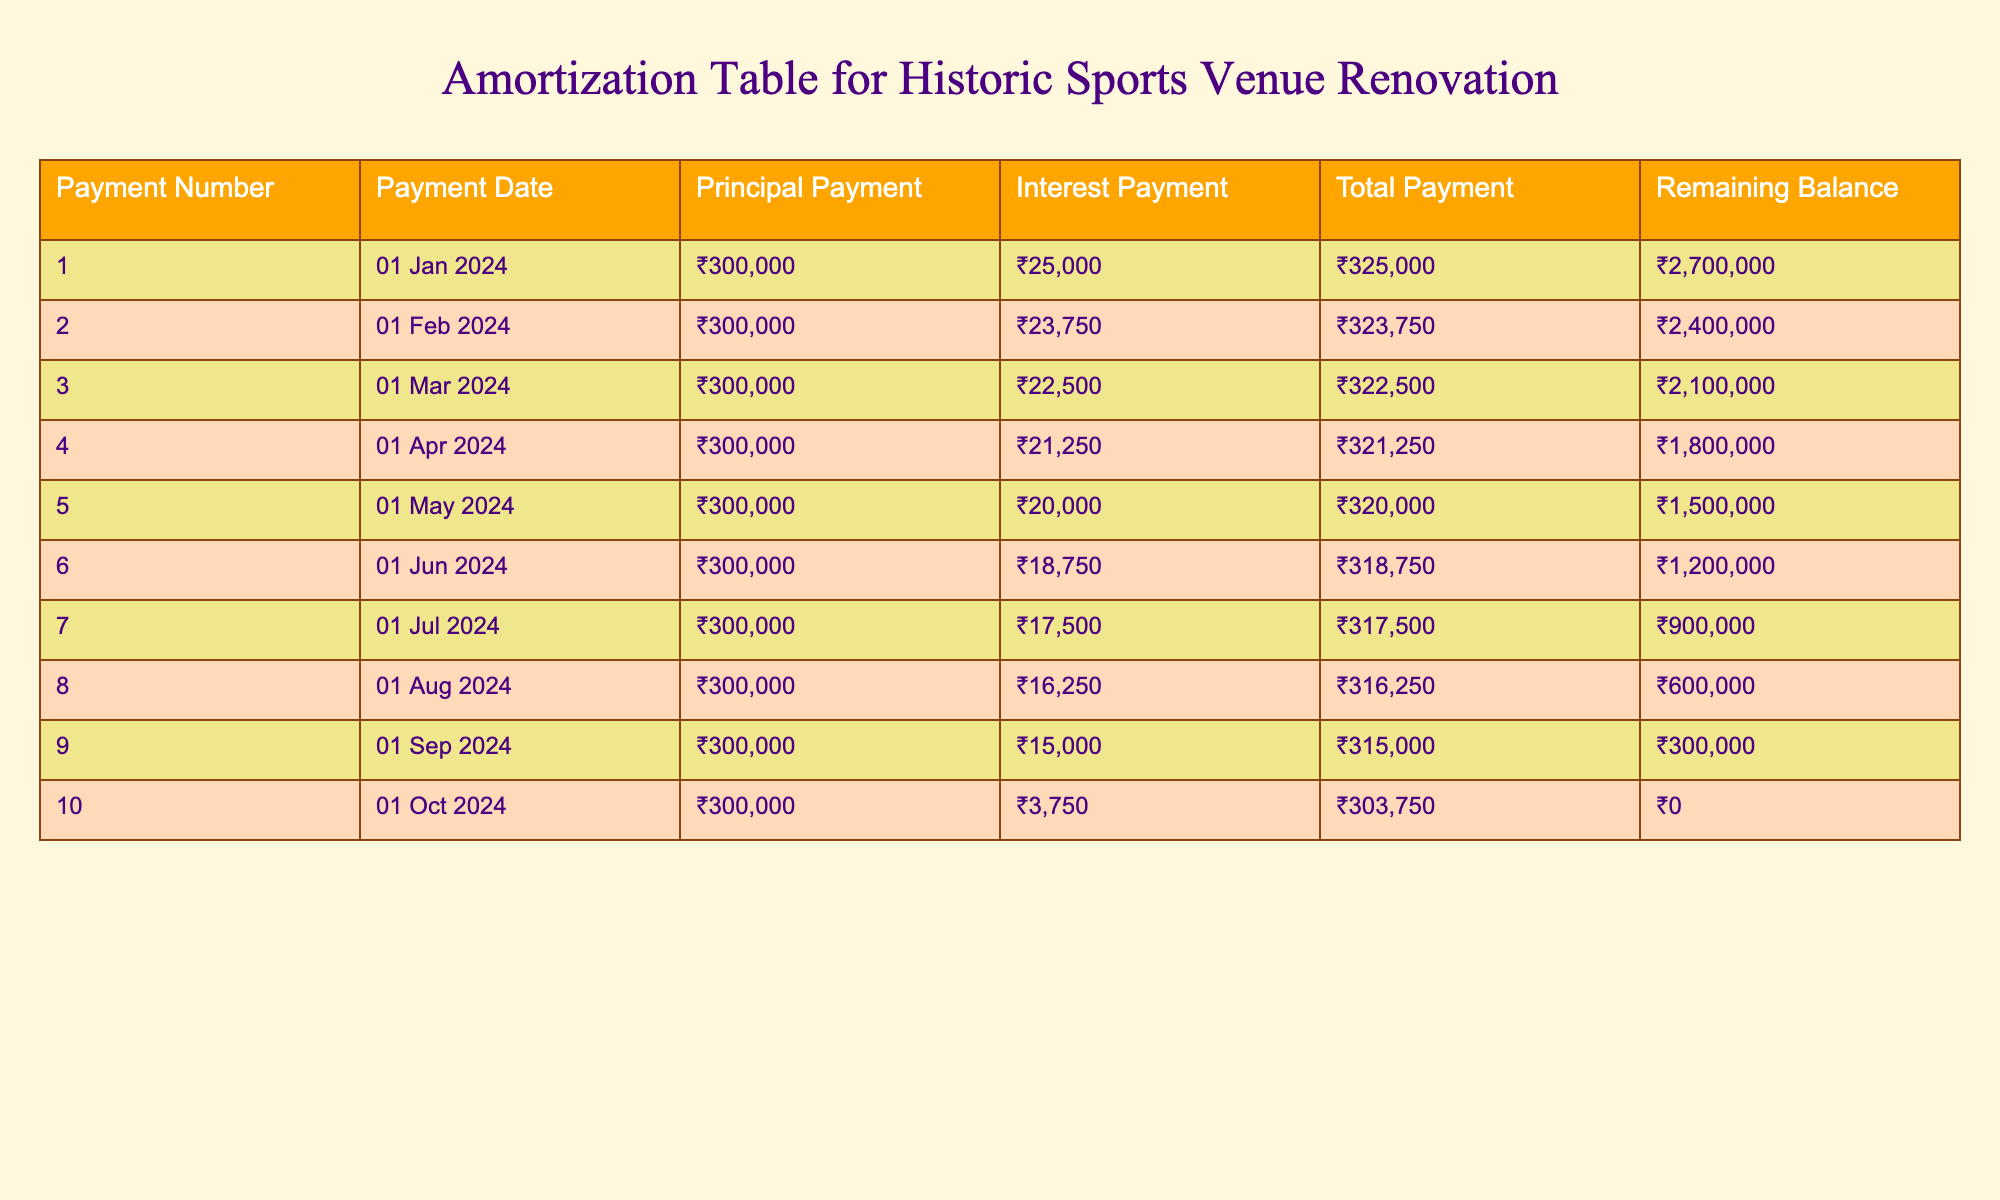What is the total payment made in the first month? The total payment for the first month is listed under the "Total Payment" column for Payment Number 1, which is ₹325,000.
Answer: ₹325,000 How much was the principal payment in the fifth month? The principal payment for the fifth month can be found in the "Principal Payment" column for Payment Number 5, which is ₹300,000.
Answer: ₹300,000 What is the remaining balance after the tenth payment? The remaining balance is shown in the "Remaining Balance" column for Payment Number 10, which indicates ₹0.
Answer: ₹0 What is the total interest paid over the ten months? The total interest paid over the ten months is the sum of the "Interest Payment" column. Summing the values (₹25,000 + ₹23,750 + ₹22,500 + ₹21,250 + ₹20,000 + ₹18,750 + ₹17,500 + ₹16,250 + ₹15,000 + ₹3,750) equals ₹194,000.
Answer: ₹194,000 Was the interest payment in the sixth month higher than in the ninth month? The interest payment in the sixth month is ₹18,750 while in the ninth month it is ₹15,000. Since ₹18,750 is greater than ₹15,000, the statement is true.
Answer: Yes What is the average principal payment made each month? There are ten months, and each month has a principal payment of ₹300,000. Thus, the average principal payment is simply ₹300,000 since all values are the same.
Answer: ₹300,000 How much did the total payments decrease from the first to the last month? The total payment in the first month is ₹325,000 and in the last month is ₹303,750. The decrease is calculated as ₹325,000 - ₹303,750 = ₹21,250.
Answer: ₹21,250 Was the principal payment consistently the same every month? Observing the "Principal Payment" column, it shows that every month has the same amount of ₹300,000, confirming that the principal payments were consistent.
Answer: Yes What percentage of the total payment was made up of interest in the third month? In the third month, the total payment is ₹322,500 and the interest payment is ₹22,500. The percentage of interest is (₹22,500 / ₹322,500) * 100, which equals approximately 6.98%.
Answer: 6.98% 